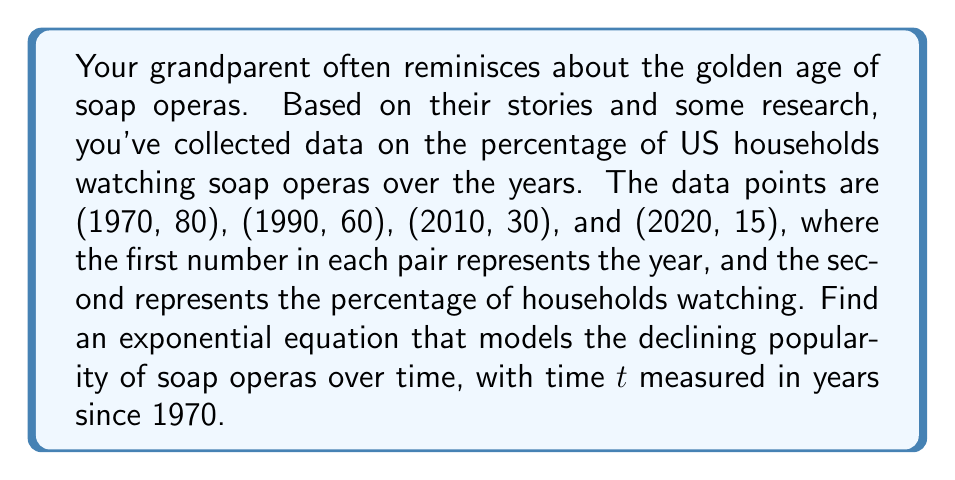Show me your answer to this math problem. Let's approach this step-by-step:

1) The general form of an exponential decay function is:
   $$y = ae^{bt}$$
   where $a$ is the initial value, $b$ is the decay rate, and $t$ is time.

2) We need to find $a$ and $b$. We know that in 1970 ($t=0$), 80% of households were watching soap operas. So $a = 80$.

3) Now we can use any other point to find $b$. Let's use (2020, 15). This is 50 years after 1970, so $t=50$.

4) Plugging this into our equation:
   $$15 = 80e^{50b}$$

5) Dividing both sides by 80:
   $$\frac{15}{80} = e^{50b}$$

6) Taking the natural log of both sides:
   $$\ln(\frac{15}{80}) = 50b$$

7) Solving for $b$:
   $$b = \frac{\ln(\frac{15}{80})}{50} \approx -0.0338$$

8) Therefore, our equation is:
   $$y = 80e^{-0.0338t}$$

Where $y$ is the percentage of households watching soap operas and $t$ is the number of years since 1970.
Answer: $y = 80e^{-0.0338t}$ 